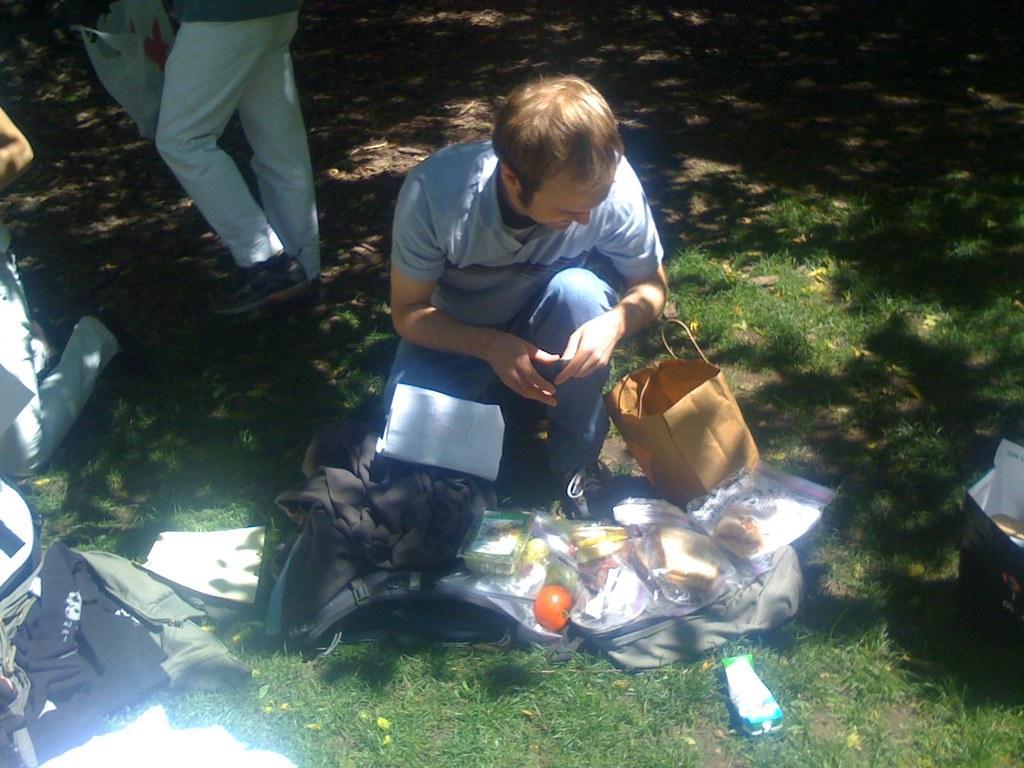Describe this image in one or two sentences. In this image I can see some food items and backpack on the grass ground, around that there are so many people. 